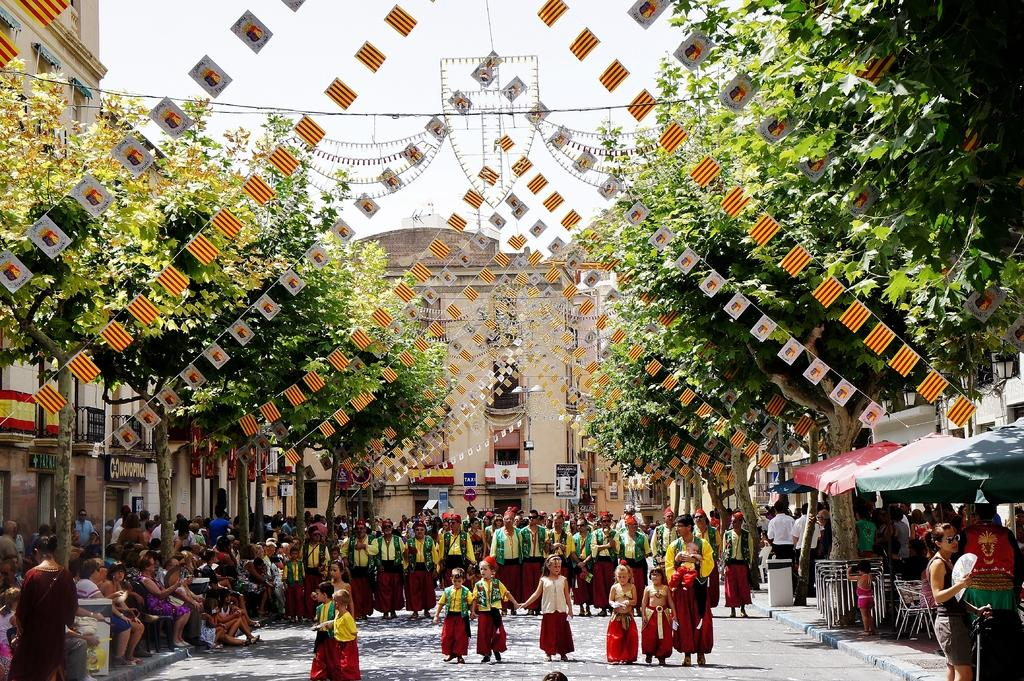What is the main subject of the image? The main subject of the image is a crowd. What can be seen in the background of the image? The sky is visible in the background of the image. What type of structures are present in the image? There are buildings in the image. What objects are being used by the people in the crowd? There are umbrellas in the image. What other items can be seen in the image? There are flags, trees, a road, and boards in the image. What type of prose is being recited by the crowd in the image? There is no indication in the image that the crowd is reciting any prose. How many spiders can be seen crawling on the buildings in the image? There are no spiders visible in the image. What shape is the square in the image? There is no square present in the image. 